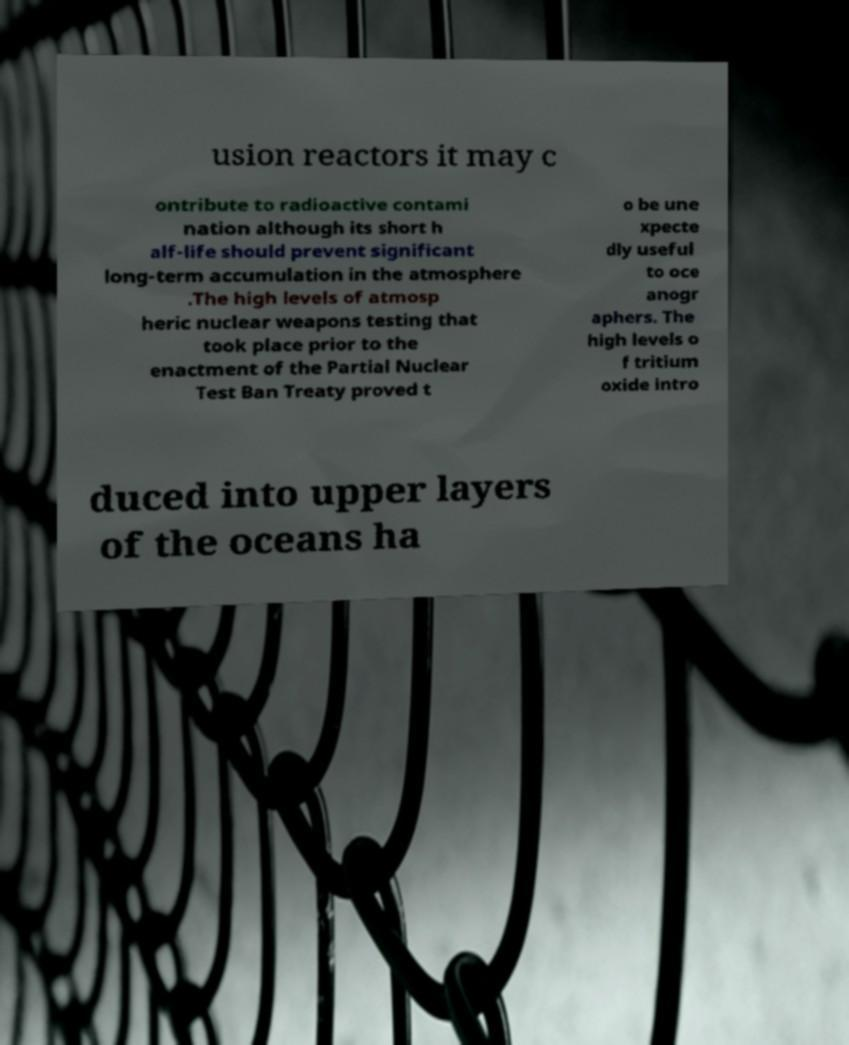Can you accurately transcribe the text from the provided image for me? usion reactors it may c ontribute to radioactive contami nation although its short h alf-life should prevent significant long-term accumulation in the atmosphere .The high levels of atmosp heric nuclear weapons testing that took place prior to the enactment of the Partial Nuclear Test Ban Treaty proved t o be une xpecte dly useful to oce anogr aphers. The high levels o f tritium oxide intro duced into upper layers of the oceans ha 